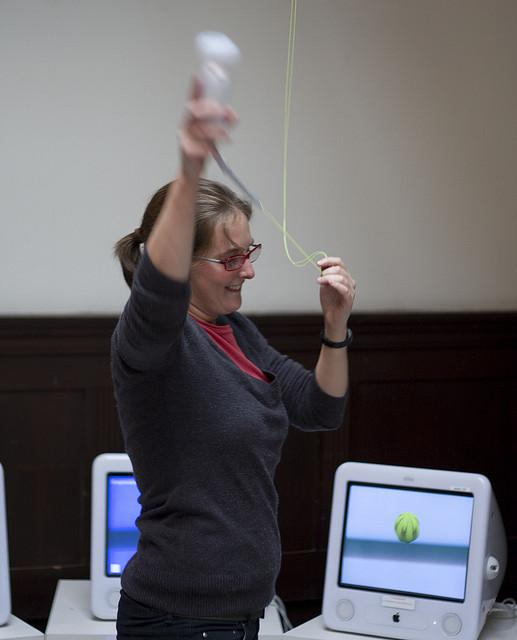What kind of computer is near the woman in blue?

Choices:
A) acer
B) macintosh
C) hp
D) dell macintosh 